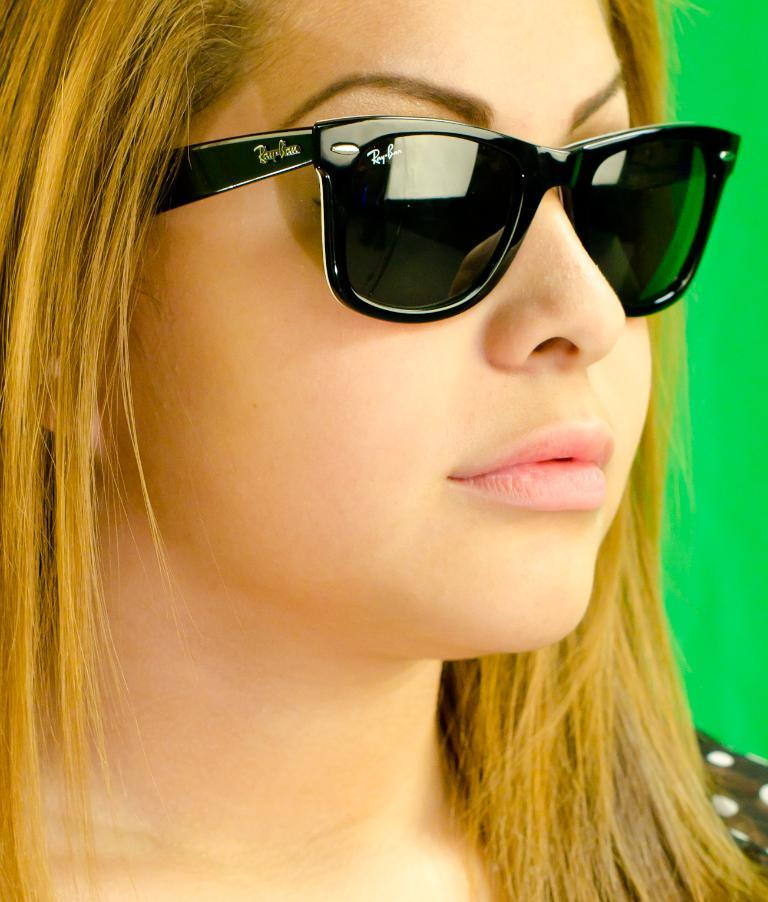Who is present in the image? There is a woman in the image. What is the woman wearing on her face? The woman is wearing goggles. What can be seen in the background of the image? There is a wall in the background of the image. What type of sand can be seen on the woman's shirt in the image? There is no sand visible on the woman's shirt in the image. How is the thread used by the woman in the image? There is no thread present in the image. 